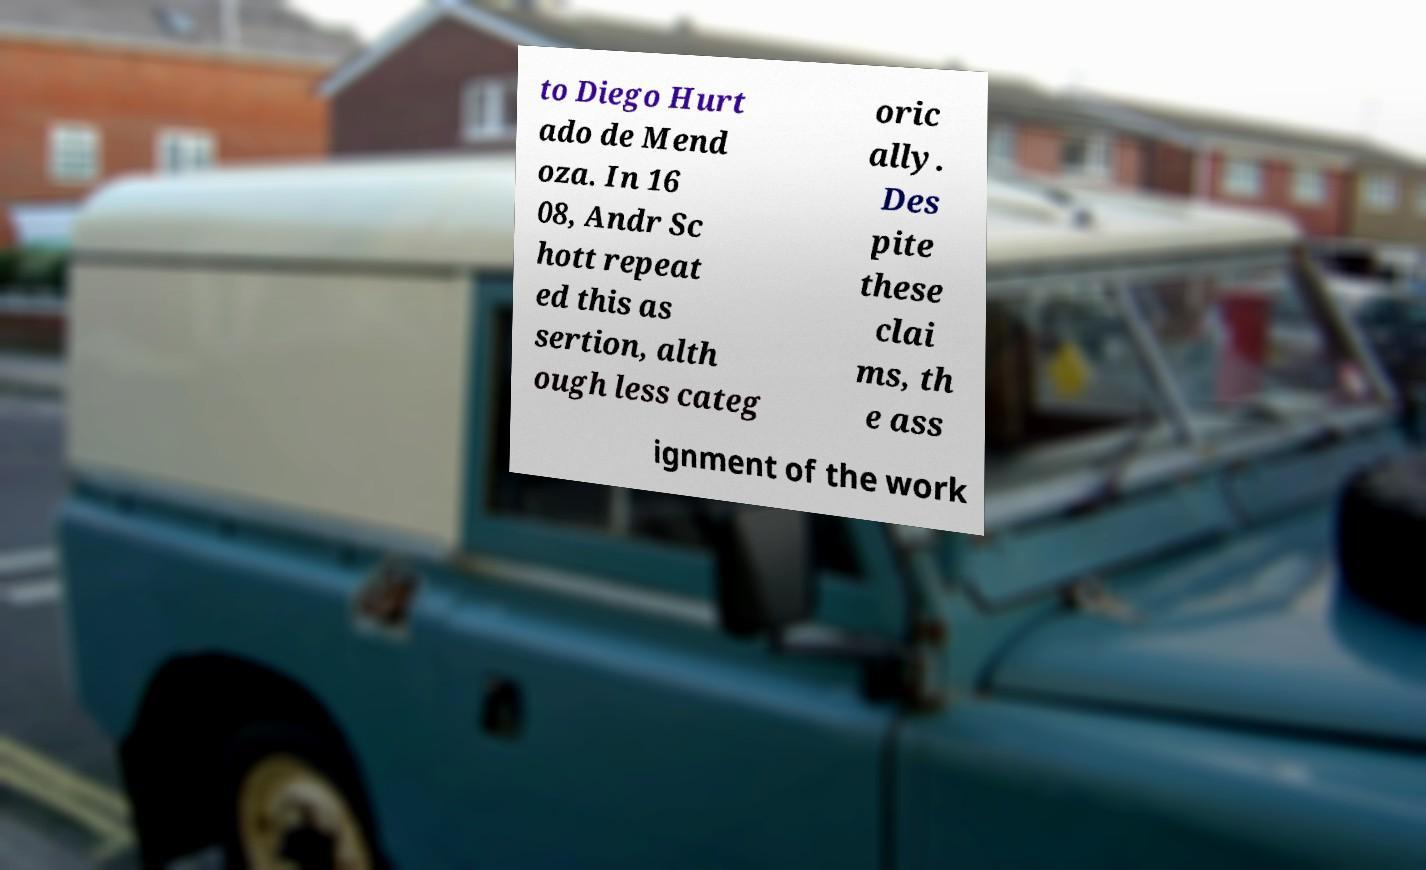I need the written content from this picture converted into text. Can you do that? to Diego Hurt ado de Mend oza. In 16 08, Andr Sc hott repeat ed this as sertion, alth ough less categ oric ally. Des pite these clai ms, th e ass ignment of the work 